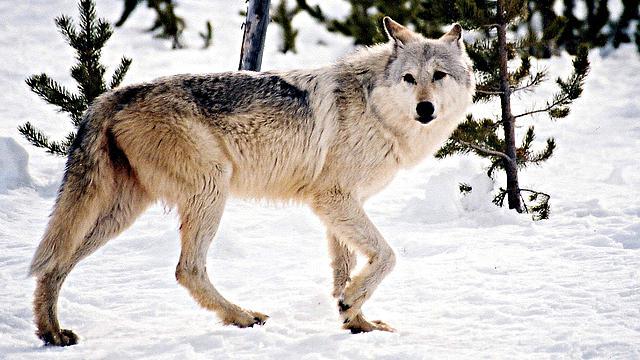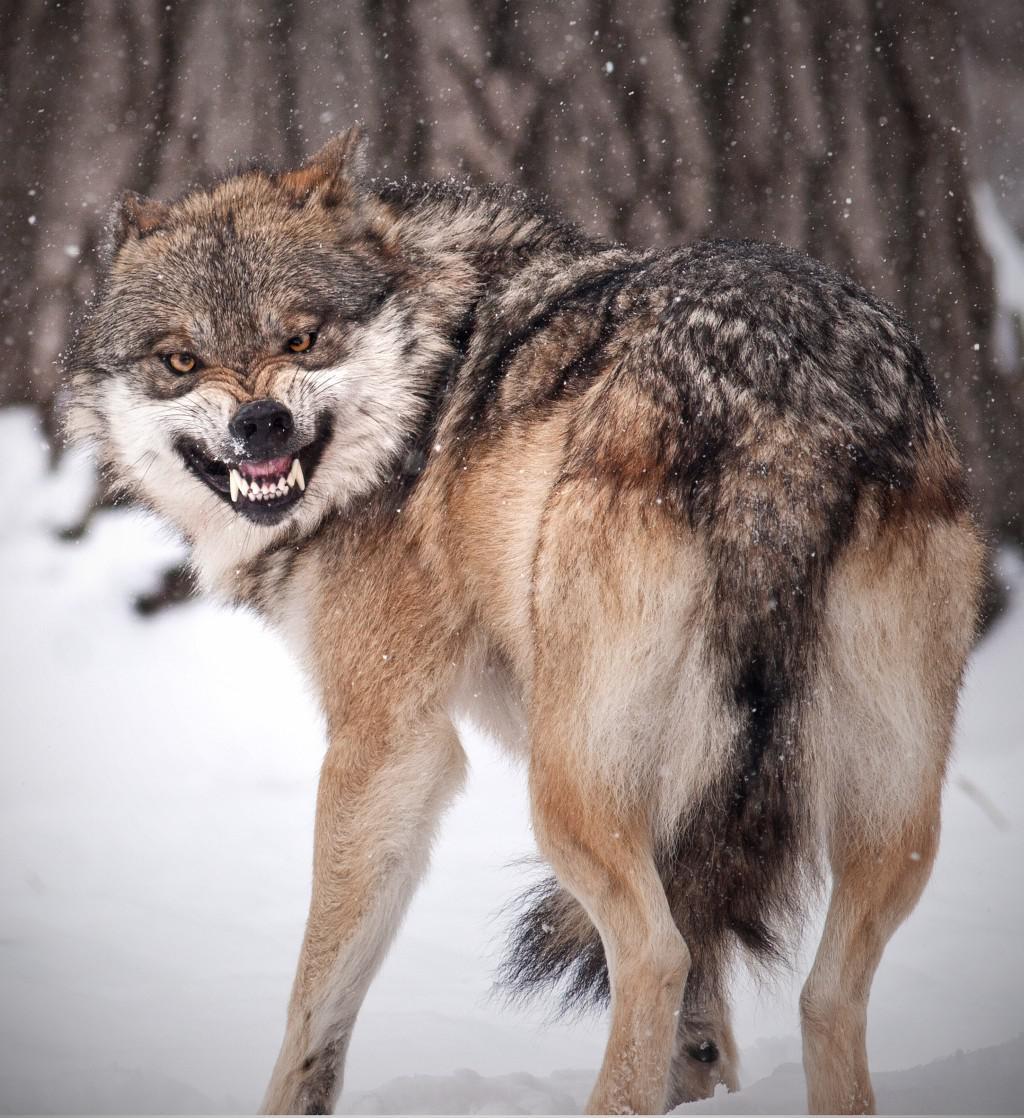The first image is the image on the left, the second image is the image on the right. For the images displayed, is the sentence "The wolf in the right image is facing towards the right." factually correct? Answer yes or no. No. The first image is the image on the left, the second image is the image on the right. Examine the images to the left and right. Is the description "One image includes at least three standing similar-looking wolves in a snowy scene." accurate? Answer yes or no. No. 